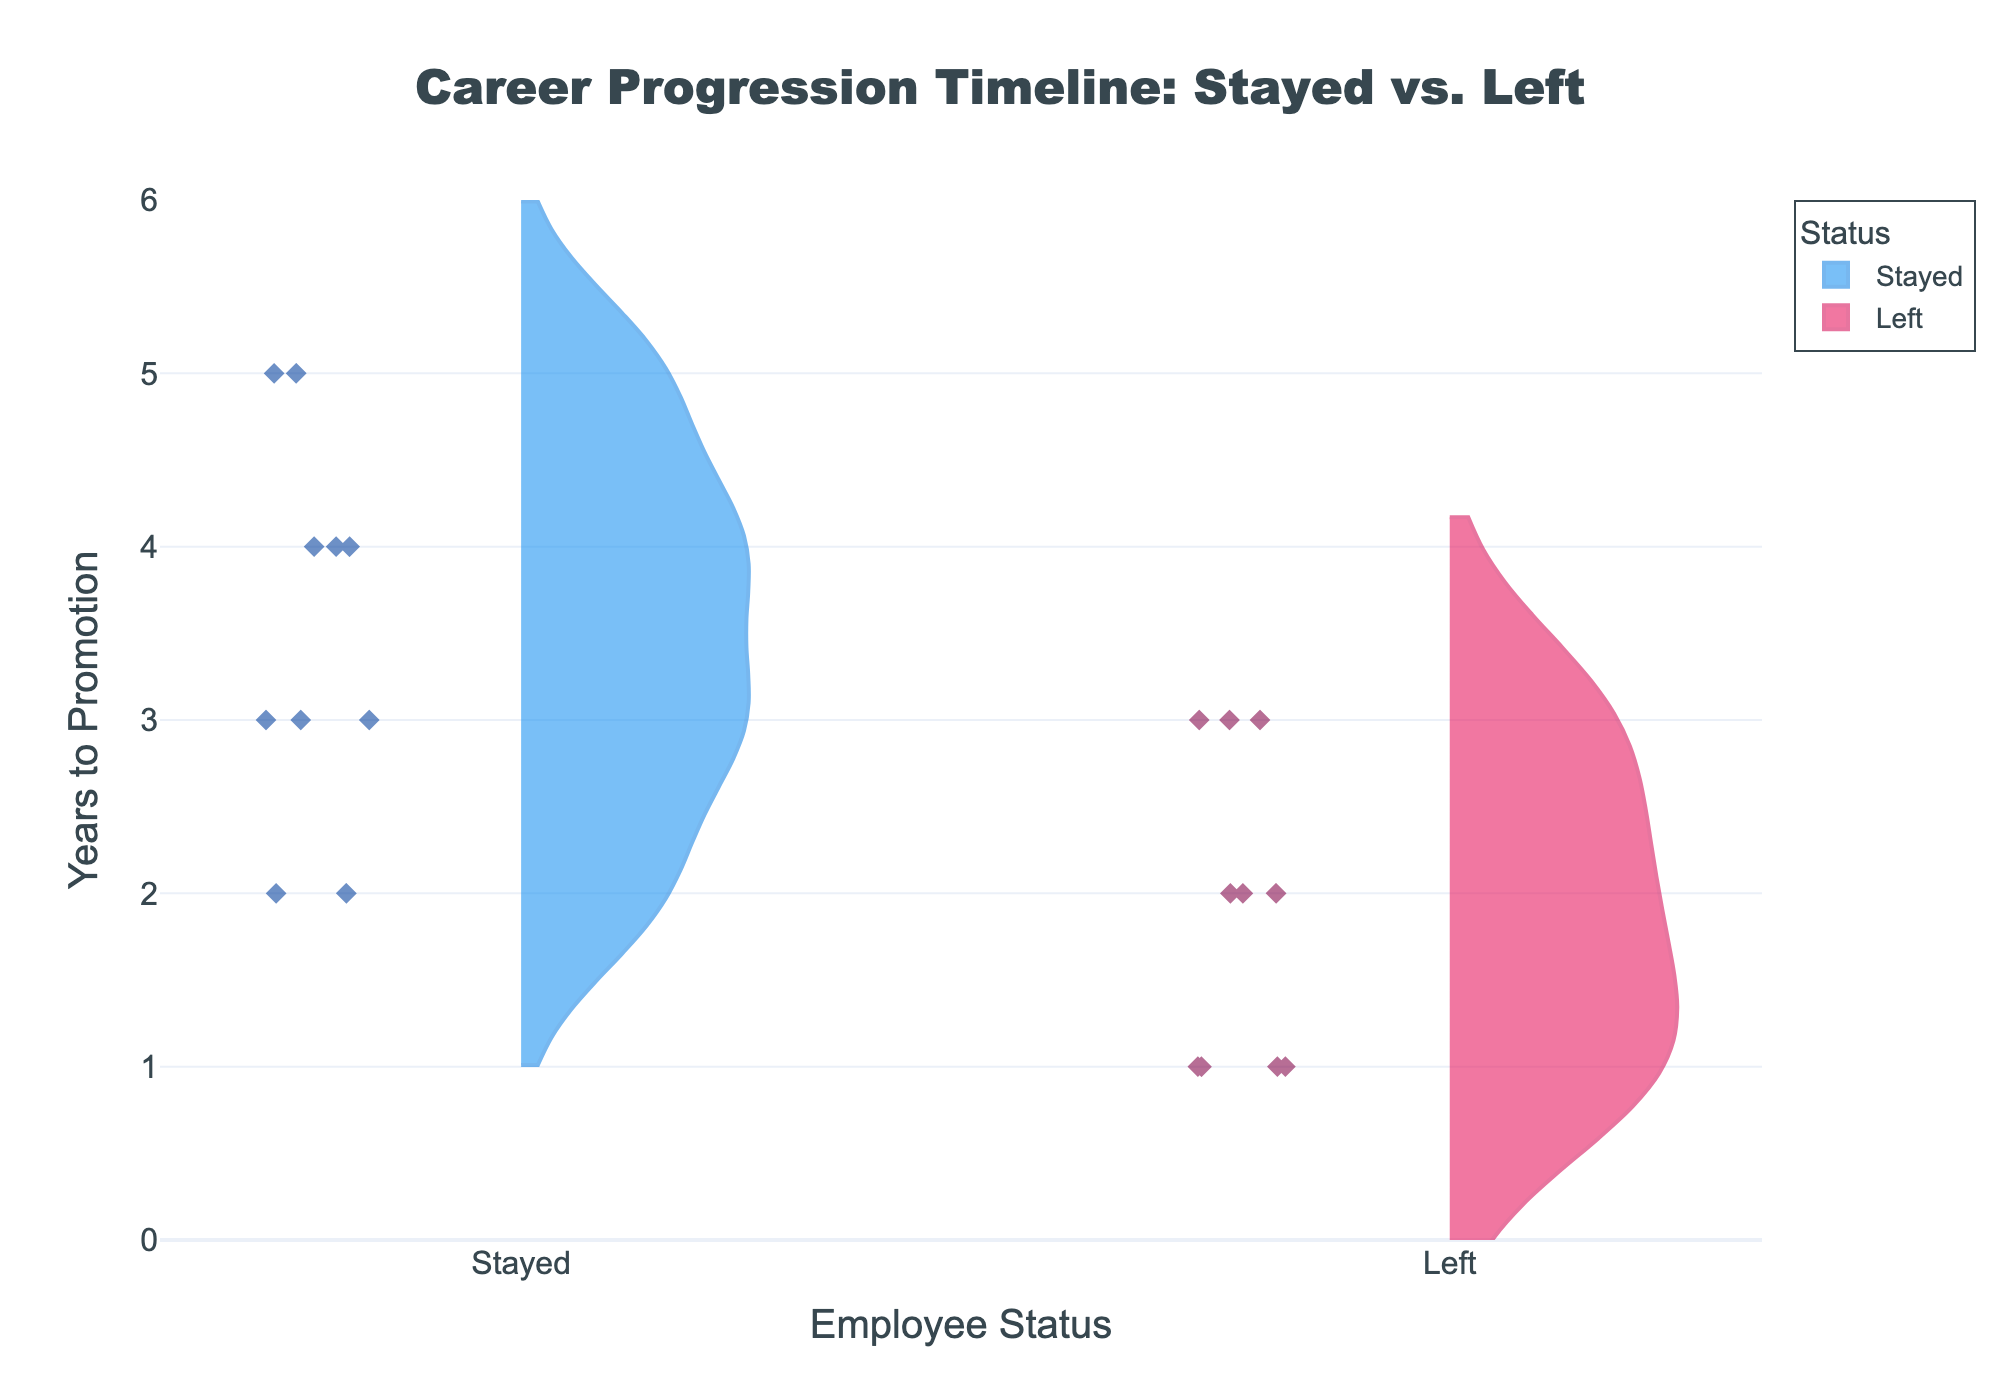What is the title of the figure? The title is prominently displayed at the top center of the figure.
Answer: Career Progression Timeline: Stayed vs. Left What does the x-axis represent? The x-axis label is located below the x-axis and displays the variable it represents.
Answer: Employee Status How many data points are there for employees who stayed? By examining the number of markers (diamond symbols) in the 'Stayed' violin plot, we can count the data points.
Answer: 10 What range of years to promotion is shown on the y-axis? The range of the y-axis is marked on the left-hand side of the figure.
Answer: 0 to 5 years Which group has a higher median years to promotion, Stayed or Left? By visually inspecting the density and distribution of the points within each violin plot, we can estimate the medians. The denser area in the middle typically indicates the median.
Answer: Stayed What is the minimum years to promotion for employees who left? Identify the lowest point within the 'Left' violin plot. The lowest individual marker indicates the minimum value.
Answer: 1 year What is the average years to promotion for employees who stayed? Count the years to promotion for each data point in the 'Stayed' group and calculate the average: (3+4+2+5+3+4+2+5+3+4) / 10.
Answer: 3.5 years Compare the spread of years to promotion between the Stayed and Left groups. Which group has a wider range? Look at the vertical spread of both violin plots. The group with the larger vertical spread (difference between maximum and minimum values) has a wider range.
Answer: Stayed What can be inferred about the career progression of employees who left compared to those who stayed? By examining the distribution and central tendency of both violin plots, we see that employees who left typically have shorter times to promotion, indicated by central clusters of data points closer to the lower end of the y-axis.
Answer: Employees who left have shorter times to promotion Given the visualization, what could be a possible reason for the difference in years to promotion between the two groups? One possible interpretation is that employees who stay longer may require more time to receive promotions due to company policies, job roles, or other factors, whereas those who leave might be more proactive in seeking faster career advancements elsewhere. This inference is based on analyzing the distribution and density of the data points.
Answer: Employees who stayed may be in roles or environments that have longer promotion timelines compared to those who left 